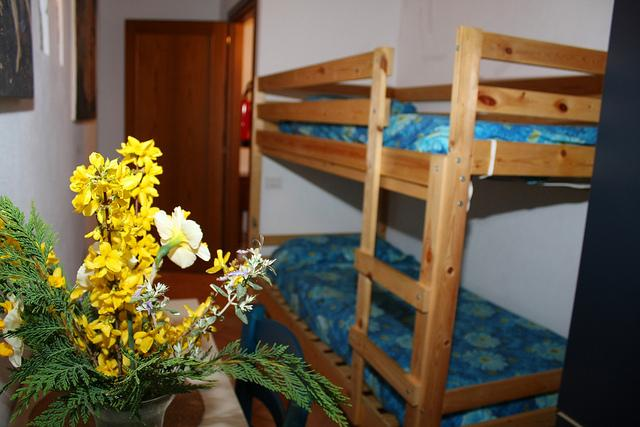What type of bed is shown?

Choices:
A) queen
B) king
C) air mattress
D) bunk bed bunk bed 